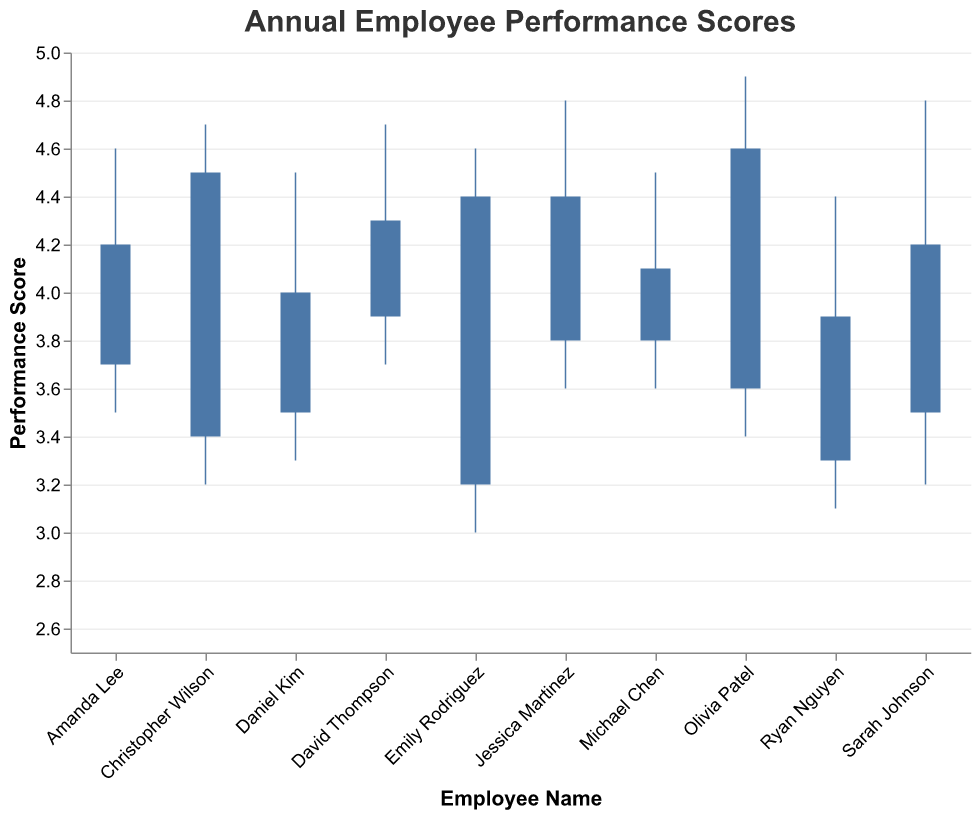What is the title of the chart? The title appears at the top of the figure and is "Annual Employee Performance Scores".
Answer: Annual Employee Performance Scores How many employees' performance scores are shown in the chart? Each bar represents one employee's performance scores. Counting the bars gives us a total of 10 employees.
Answer: 10 Who has the highest closing performance score? By examining the ending position of the bars, Olivia Patel has the highest closing performance score of 4.6.
Answer: Olivia Patel What is the range of Michael Chen's performance scores? Michael Chen's scores range from his lowest (3.6) to his highest (4.5).
Answer: 3.6 to 4.5 Which employee shows the greatest improvement in performance from Opening to Closing? Improvement can be observed as the difference between closing and opening scores. Emily Rodriguez has the most improvement with a closing score (4.4) minus the opening score (3.2), producing a difference of 1.2.
Answer: Emily Rodriguez Whose performance dropped the most from their highest point to their closing score? Calculating the difference between the High and Closing scores for each employee shows that Ryan Nguyen's performance dropped the most (4.4 - 3.9 = 0.5).
Answer: Ryan Nguyen Who has the smallest range between their lowest and highest performance scores? The range is calculated by subtracting the low score from the high score for each employee. Michael Chen has the smallest range, with scores ranging from 3.6 to 4.5, creating a range of 0.9.
Answer: Michael Chen What is the median closing performance score of all employees? To find the median, list all closing scores in order (3.9, 4.0, 4.1, 4.2, 4.2, 4.3, 4.4, 4.4, 4.5, 4.6) and the middle value between the 5th and 6th value is the median: (4.2 + 4.3) / 2 = 4.25.
Answer: 4.25 Which employee has the highest range of performance scores over the year? Range is found by subtracting the lowest score from the highest for each employee. Olivia Patel has the highest range, with scores from 3.4 to 4.9, creating a range of 1.5.
Answer: Olivia Patel Which employee had a lower closing score compared to their opening score? Comparing the closing and opening scores for each employee, only Ryan Nguyen had a lower closing score (3.9) compared to his opening score (3.3).
Answer: Ryan Nguyen 